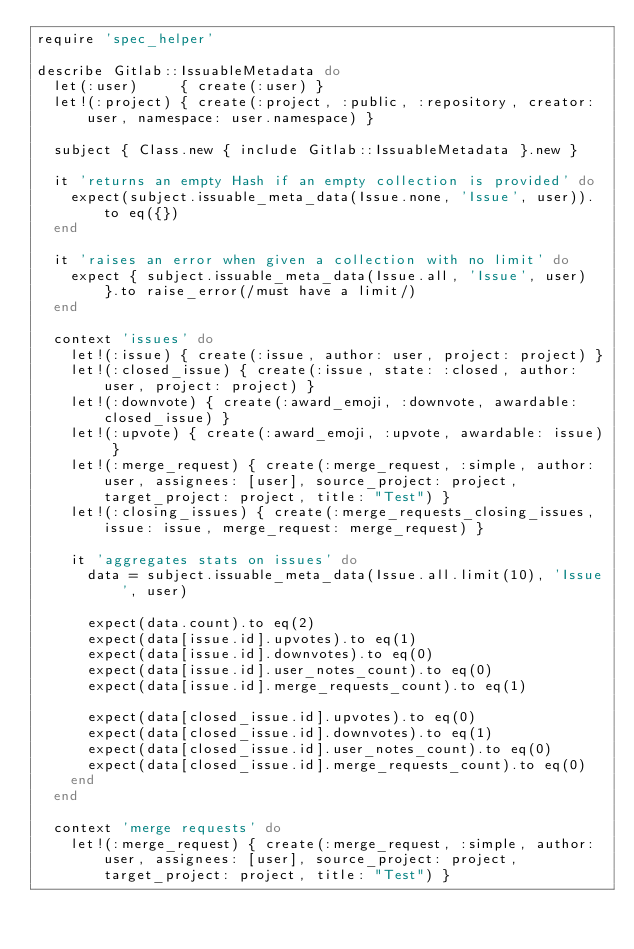<code> <loc_0><loc_0><loc_500><loc_500><_Ruby_>require 'spec_helper'

describe Gitlab::IssuableMetadata do
  let(:user)     { create(:user) }
  let!(:project) { create(:project, :public, :repository, creator: user, namespace: user.namespace) }

  subject { Class.new { include Gitlab::IssuableMetadata }.new }

  it 'returns an empty Hash if an empty collection is provided' do
    expect(subject.issuable_meta_data(Issue.none, 'Issue', user)).to eq({})
  end

  it 'raises an error when given a collection with no limit' do
    expect { subject.issuable_meta_data(Issue.all, 'Issue', user) }.to raise_error(/must have a limit/)
  end

  context 'issues' do
    let!(:issue) { create(:issue, author: user, project: project) }
    let!(:closed_issue) { create(:issue, state: :closed, author: user, project: project) }
    let!(:downvote) { create(:award_emoji, :downvote, awardable: closed_issue) }
    let!(:upvote) { create(:award_emoji, :upvote, awardable: issue) }
    let!(:merge_request) { create(:merge_request, :simple, author: user, assignees: [user], source_project: project, target_project: project, title: "Test") }
    let!(:closing_issues) { create(:merge_requests_closing_issues, issue: issue, merge_request: merge_request) }

    it 'aggregates stats on issues' do
      data = subject.issuable_meta_data(Issue.all.limit(10), 'Issue', user)

      expect(data.count).to eq(2)
      expect(data[issue.id].upvotes).to eq(1)
      expect(data[issue.id].downvotes).to eq(0)
      expect(data[issue.id].user_notes_count).to eq(0)
      expect(data[issue.id].merge_requests_count).to eq(1)

      expect(data[closed_issue.id].upvotes).to eq(0)
      expect(data[closed_issue.id].downvotes).to eq(1)
      expect(data[closed_issue.id].user_notes_count).to eq(0)
      expect(data[closed_issue.id].merge_requests_count).to eq(0)
    end
  end

  context 'merge requests' do
    let!(:merge_request) { create(:merge_request, :simple, author: user, assignees: [user], source_project: project, target_project: project, title: "Test") }</code> 